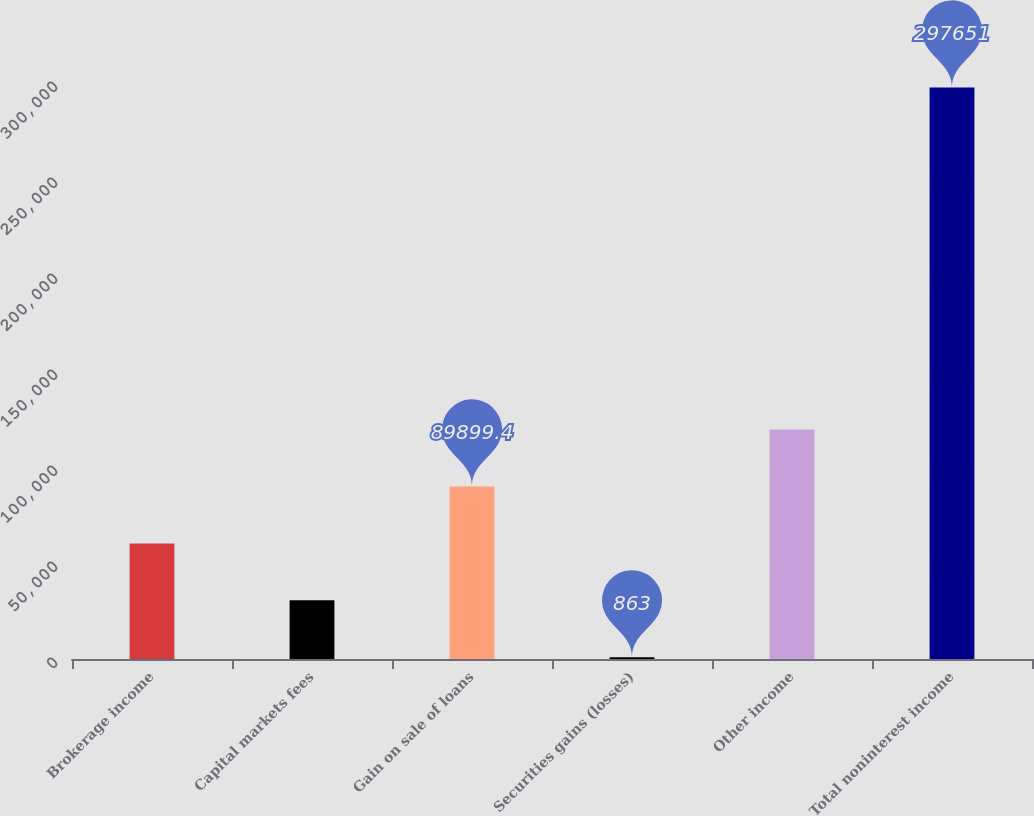Convert chart to OTSL. <chart><loc_0><loc_0><loc_500><loc_500><bar_chart><fcel>Brokerage income<fcel>Capital markets fees<fcel>Gain on sale of loans<fcel>Securities gains (losses)<fcel>Other income<fcel>Total noninterest income<nl><fcel>60220.6<fcel>30541.8<fcel>89899.4<fcel>863<fcel>119578<fcel>297651<nl></chart> 